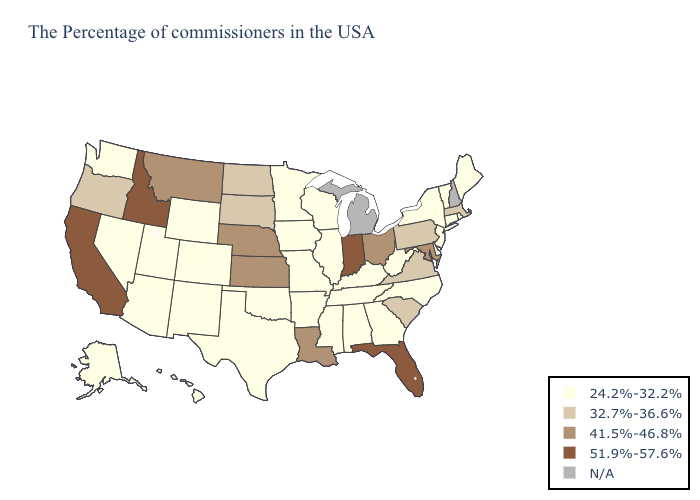Does California have the highest value in the USA?
Quick response, please. Yes. Name the states that have a value in the range 41.5%-46.8%?
Short answer required. Maryland, Ohio, Louisiana, Kansas, Nebraska, Montana. Name the states that have a value in the range 51.9%-57.6%?
Give a very brief answer. Florida, Indiana, Idaho, California. What is the lowest value in the West?
Be succinct. 24.2%-32.2%. What is the value of Maine?
Be succinct. 24.2%-32.2%. Is the legend a continuous bar?
Answer briefly. No. Does the first symbol in the legend represent the smallest category?
Give a very brief answer. Yes. Which states have the lowest value in the USA?
Give a very brief answer. Maine, Rhode Island, Vermont, Connecticut, New York, New Jersey, Delaware, North Carolina, West Virginia, Georgia, Kentucky, Alabama, Tennessee, Wisconsin, Illinois, Mississippi, Missouri, Arkansas, Minnesota, Iowa, Oklahoma, Texas, Wyoming, Colorado, New Mexico, Utah, Arizona, Nevada, Washington, Alaska, Hawaii. What is the value of Connecticut?
Answer briefly. 24.2%-32.2%. What is the value of Florida?
Give a very brief answer. 51.9%-57.6%. Does Hawaii have the lowest value in the USA?
Be succinct. Yes. What is the value of California?
Keep it brief. 51.9%-57.6%. Among the states that border Connecticut , which have the highest value?
Concise answer only. Massachusetts. What is the highest value in the MidWest ?
Write a very short answer. 51.9%-57.6%. 